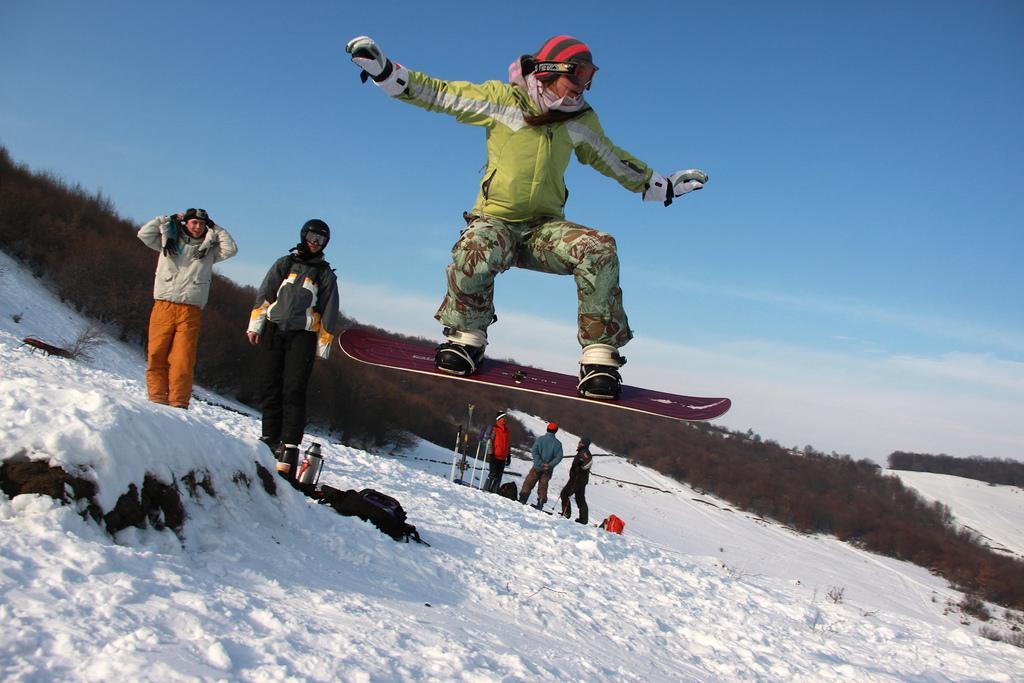Question: what is this a picture of?
Choices:
A. Winter sports.
B. A person.
C. An outdoor scene.
D. Someone snowboarding.
Answer with the letter. Answer: D Question: when was this picture taken?
Choices:
A. Morning.
B. Evening.
C. In the winter.
D. Day time.
Answer with the letter. Answer: D Question: where was this picture taken?
Choices:
A. In the snow.
B. Outside.
C. At a beach.
D. At a ski lodge.
Answer with the letter. Answer: A Question: who is in the picture?
Choices:
A. Skiers.
B. Hikers.
C. Sledders.
D. Snowboarders.
Answer with the letter. Answer: D Question: how many people are in the picture?
Choices:
A. Seven.
B. Two.
C. Eight.
D. Six.
Answer with the letter. Answer: D Question: what is in the background?
Choices:
A. Mountains.
B. Grassy area.
C. Lake.
D. Trees.
Answer with the letter. Answer: B Question: why is he wearing goggles?
Choices:
A. To protect his eyes.
B. To see better.
C. To look cool.
D. As a joke.
Answer with the letter. Answer: A Question: who is watching snowboarder?
Choices:
A. The audience.
B. His friends.
C. Two people.
D. Onlookers.
Answer with the letter. Answer: C Question: what is the snowboarder wearing?
Choices:
A. A ski jacket.
B. Black boots.
C. Goggles.
D. Thick gloves.
Answer with the letter. Answer: C Question: what is on the ground?
Choices:
A. Twigs.
B. Water.
C. Sand.
D. Snow.
Answer with the letter. Answer: D Question: who is wearing orange pants?
Choices:
A. The little boy.
B. The president.
C. The teacher.
D. A woman.
Answer with the letter. Answer: D Question: what is on the snowboarder's pants?
Choices:
A. Camouflage print.
B. Stripes down the side.
C. Zippers on the sides.
D. Sparkles.
Answer with the letter. Answer: A Question: what is on the hill?
Choices:
A. Trees.
B. Skiers.
C. Lots of snow.
D. Animals.
Answer with the letter. Answer: C Question: what is next to backpack on ground?
Choices:
A. Thermos.
B. Cooler.
C. Backpack.
D. Picnic basket.
Answer with the letter. Answer: A Question: who is facing the opposite direction?
Choices:
A. Three people in picture.
B. The man.
C. The woman.
D. The men.
Answer with the letter. Answer: A Question: where is picture?
Choices:
A. A beach.
B. A hiking trail.
C. On the ski slopes.
D. Zoo.
Answer with the letter. Answer: C Question: what is orange?
Choices:
A. Sun.
B. Shirt.
C. Glasses.
D. Shoes.
Answer with the letter. Answer: C Question: what is green?
Choices:
A. Ski jacket.
B. Boots.
C. Pants.
D. Umbrella.
Answer with the letter. Answer: A 